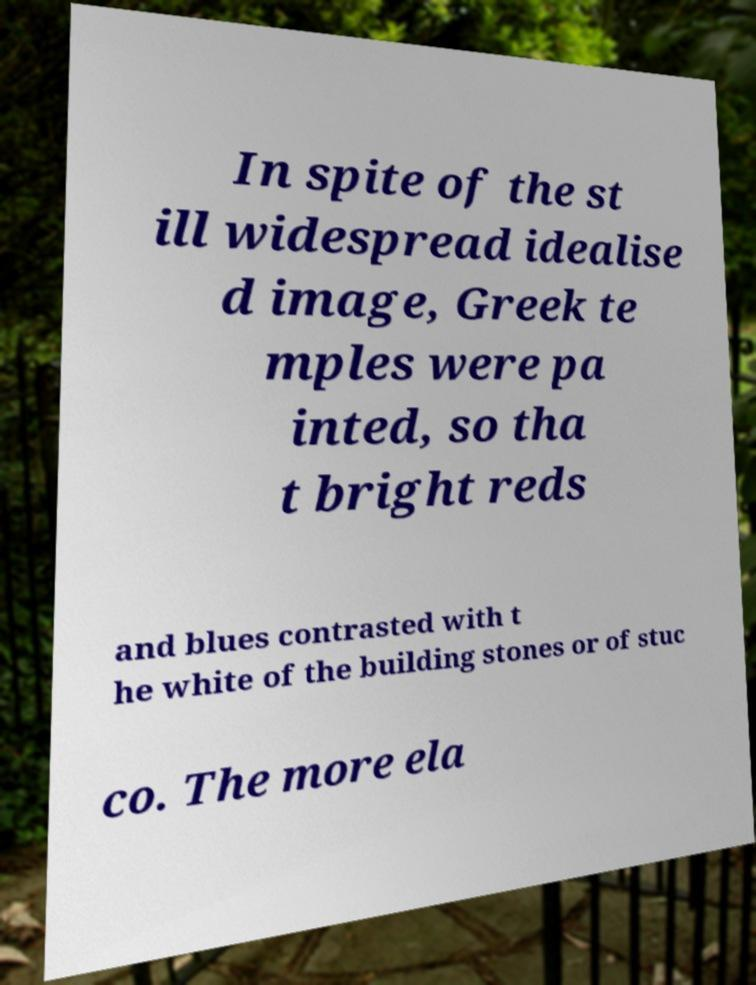Please read and relay the text visible in this image. What does it say? In spite of the st ill widespread idealise d image, Greek te mples were pa inted, so tha t bright reds and blues contrasted with t he white of the building stones or of stuc co. The more ela 